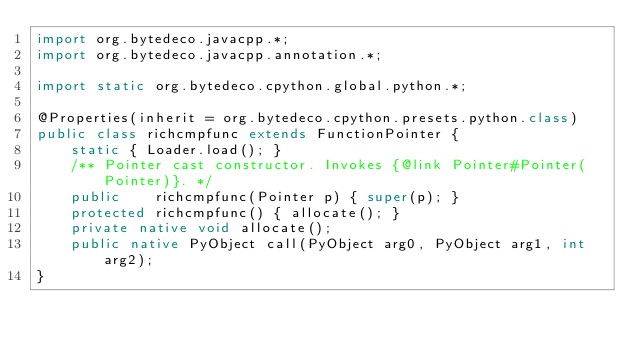<code> <loc_0><loc_0><loc_500><loc_500><_Java_>import org.bytedeco.javacpp.*;
import org.bytedeco.javacpp.annotation.*;

import static org.bytedeco.cpython.global.python.*;

@Properties(inherit = org.bytedeco.cpython.presets.python.class)
public class richcmpfunc extends FunctionPointer {
    static { Loader.load(); }
    /** Pointer cast constructor. Invokes {@link Pointer#Pointer(Pointer)}. */
    public    richcmpfunc(Pointer p) { super(p); }
    protected richcmpfunc() { allocate(); }
    private native void allocate();
    public native PyObject call(PyObject arg0, PyObject arg1, int arg2);
}
</code> 